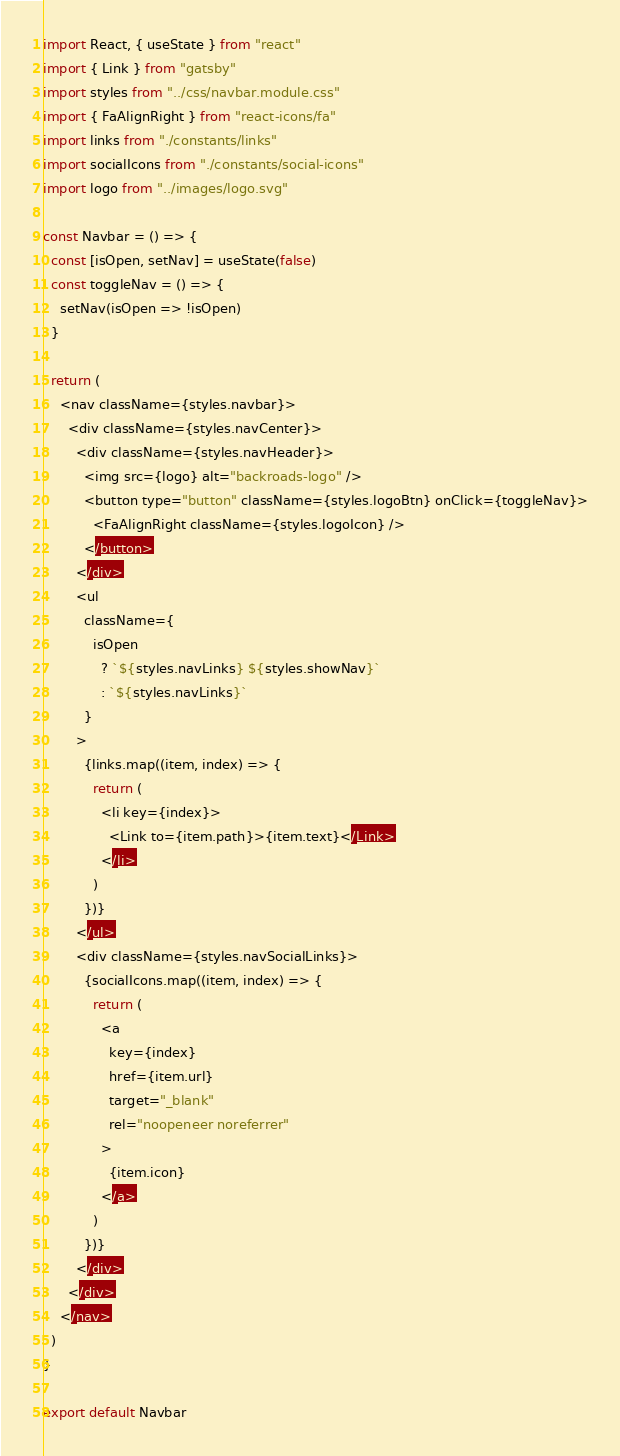Convert code to text. <code><loc_0><loc_0><loc_500><loc_500><_JavaScript_>import React, { useState } from "react"
import { Link } from "gatsby"
import styles from "../css/navbar.module.css"
import { FaAlignRight } from "react-icons/fa"
import links from "./constants/links"
import socialIcons from "./constants/social-icons"
import logo from "../images/logo.svg"

const Navbar = () => {
  const [isOpen, setNav] = useState(false)
  const toggleNav = () => {
    setNav(isOpen => !isOpen)
  }

  return (
    <nav className={styles.navbar}>
      <div className={styles.navCenter}>
        <div className={styles.navHeader}>
          <img src={logo} alt="backroads-logo" />
          <button type="button" className={styles.logoBtn} onClick={toggleNav}>
            <FaAlignRight className={styles.logoIcon} />
          </button>
        </div>
        <ul
          className={
            isOpen
              ? `${styles.navLinks} ${styles.showNav}`
              : `${styles.navLinks}`
          }
        >
          {links.map((item, index) => {
            return (
              <li key={index}>
                <Link to={item.path}>{item.text}</Link>
              </li>
            )
          })}
        </ul>
        <div className={styles.navSocialLinks}>
          {socialIcons.map((item, index) => {
            return (
              <a
                key={index}
                href={item.url}
                target="_blank"
                rel="noopeneer noreferrer"
              >
                {item.icon}
              </a>
            )
          })}
        </div>
      </div>
    </nav>
  )
}

export default Navbar
</code> 